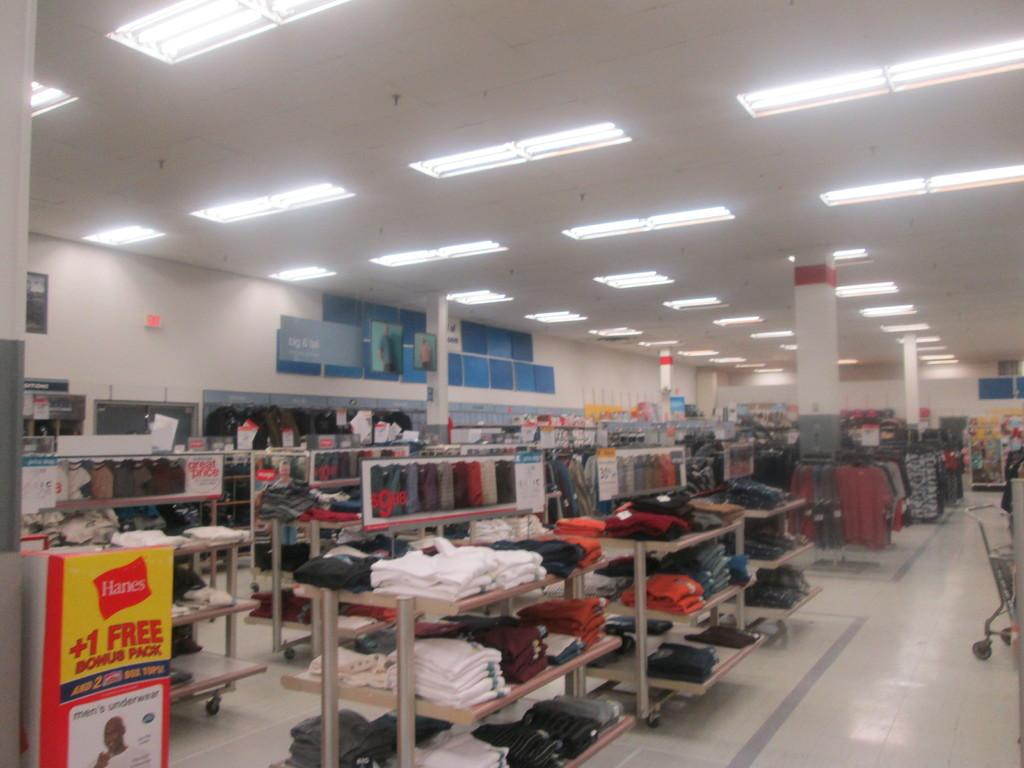<image>
Describe the image concisely. Hanes clothing in a store where you get a free bonus pack. 